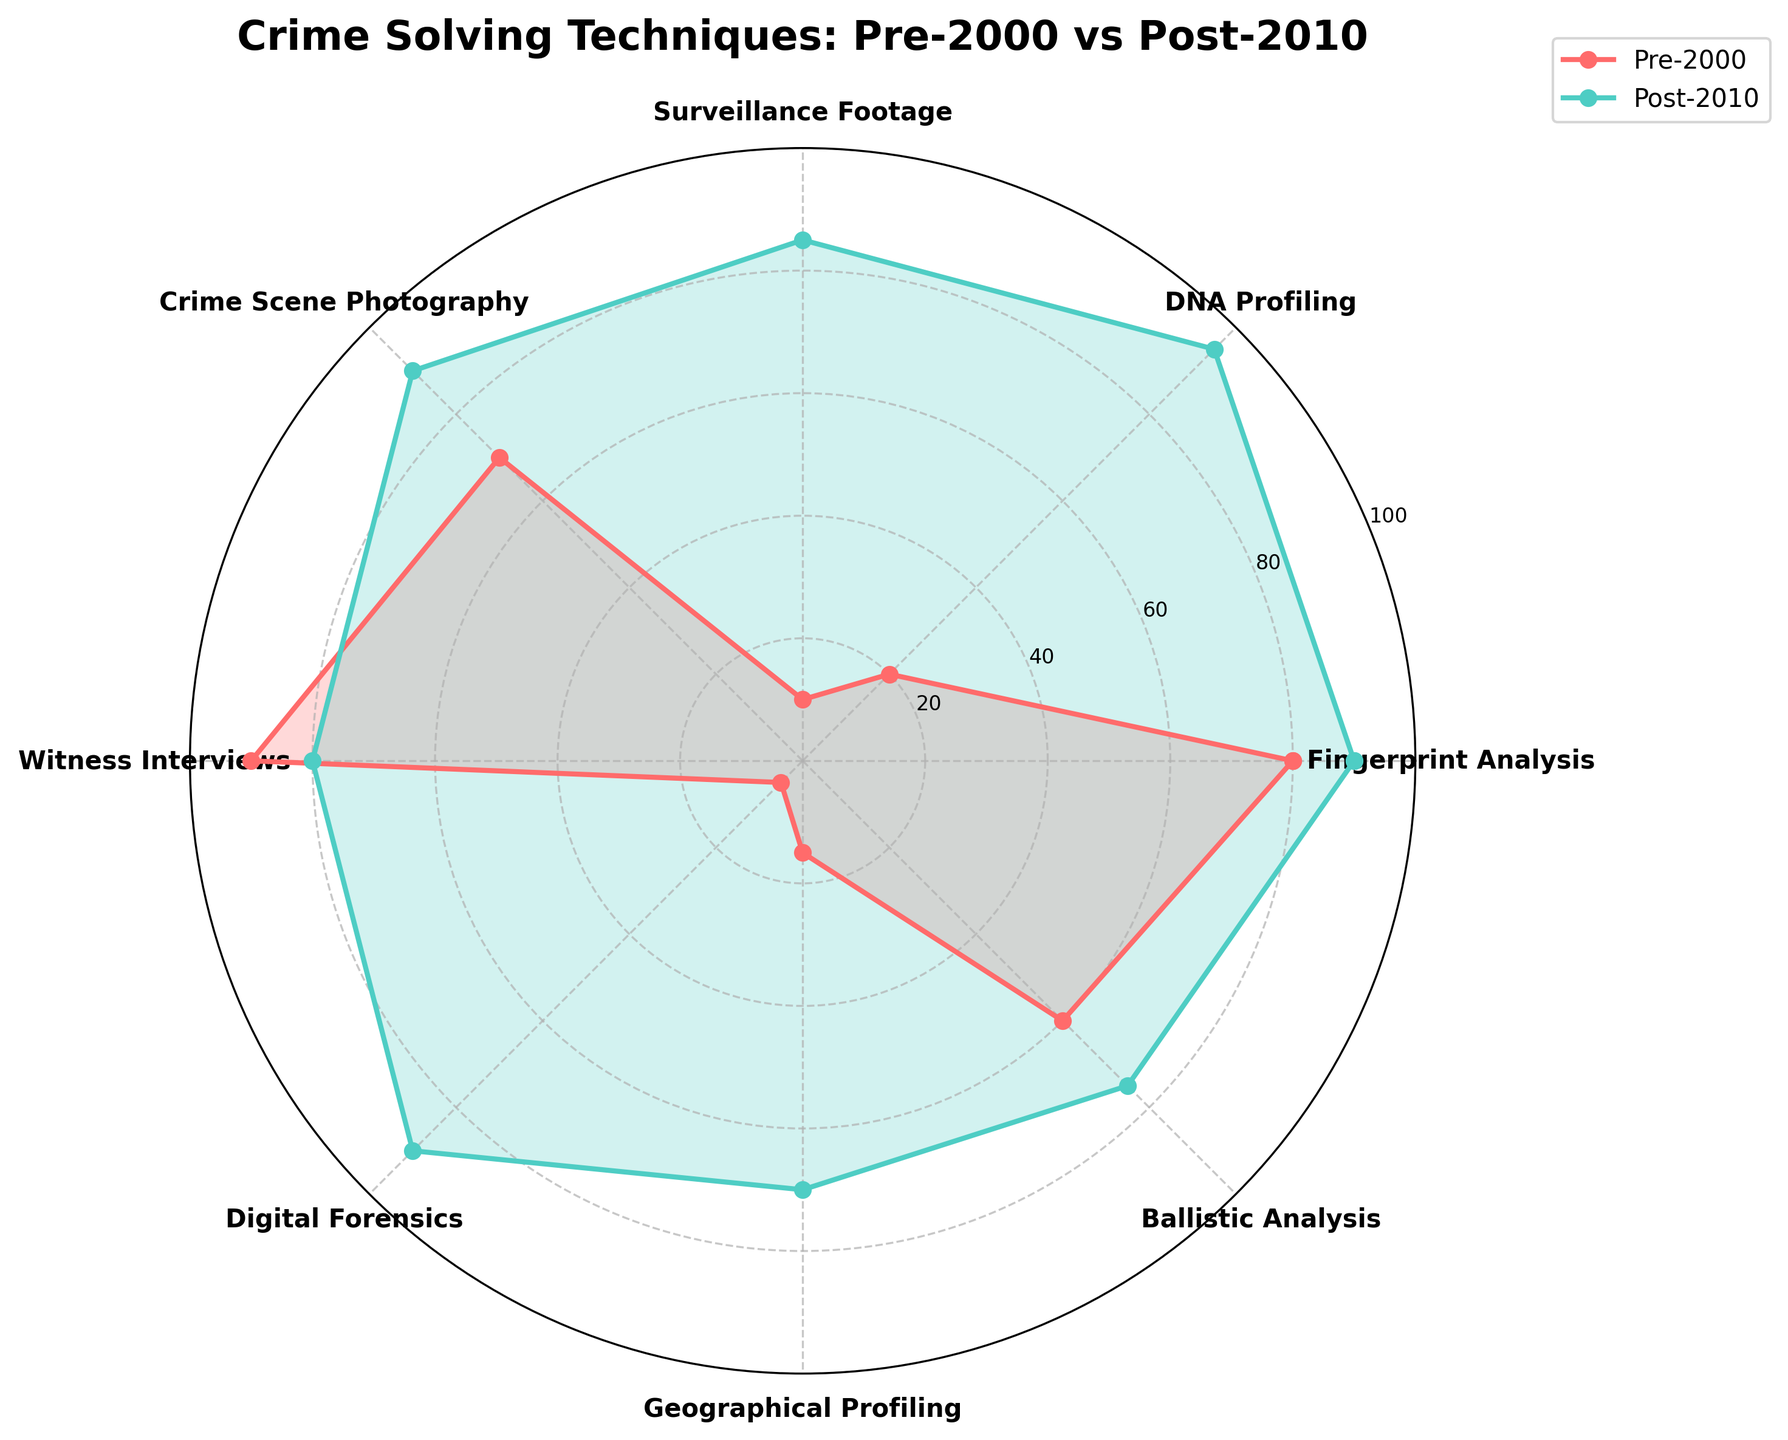What's the title of the radar chart? The title is usually located at the top of the chart. By examining the figure, you can see it labeled "Crime Solving Techniques: Pre-2000 vs Post-2010".
Answer: Crime Solving Techniques: Pre-2000 vs Post-2010 Which crime-solving technique had the largest increase in usage from Pre-2000 to Post-2010? To find the largest increase, calculate the difference between the values for each technique in the Post-2010 line and the Pre-2000 line. The technique with the largest positive difference is DNA Profiling (95 - 20 = 75).
Answer: DNA Profiling What color is used to represent the Post-2010 data points? The legend or the lines filling the radar chart indicate the color used for each time period. The Post-2010 data points are represented by a teal-like color.
Answer: Teal Which technique showed the smallest change between Pre-2000 and Post-2010? To find the smallest change, compute the absolute difference between Pre-2000 and Post-2010 values for each technique. Here, Witness Interviews shows the smallest change (90 - 80 = 10).
Answer: Witness Interviews How many techniques had higher usage in Post-2010 compared to Pre-2000? Compare each technique's Post-2010 value with its Pre-2000 value. Count how many techniques have higher values in Post-2010. There are seven such techniques.
Answer: Seven What's the average usage of Surveillance Footage between Pre-2000 and Post-2010? Add the values of Surveillance Footage for Pre-2000 (10) and Post-2010 (85), then divide by 2 to get the average. (10 + 85) / 2 = 47.5
Answer: 47.5 Did any technique show a decrease in importance from Pre-2000 to Post-2010? Compare each technique. Witness Interviews decreased from 90 to 80.
Answer: Yes, Witness Interviews For which techniques are the Pre-2000 and Post-2010 values closest to each other? Calculate absolute differences for each technique and find the smallest one. Witness Interviews has the smallest difference of 10 (90 - 80 = 10).
Answer: Witness Interviews Which technique appears at the 12 o'clock position on the radar chart? The techniques are positioned around the radar chart corresponding to the circle. The first technique listed usually starts at the top (12 o'clock position). Here, it is Fingerprint Analysis.
Answer: Fingerprint Analysis 